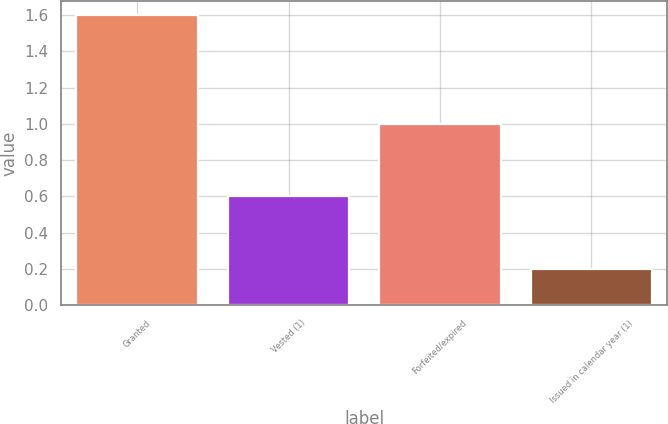Convert chart to OTSL. <chart><loc_0><loc_0><loc_500><loc_500><bar_chart><fcel>Granted<fcel>Vested (1)<fcel>Forfeited/expired<fcel>Issued in calendar year (1)<nl><fcel>1.6<fcel>0.6<fcel>1<fcel>0.2<nl></chart> 